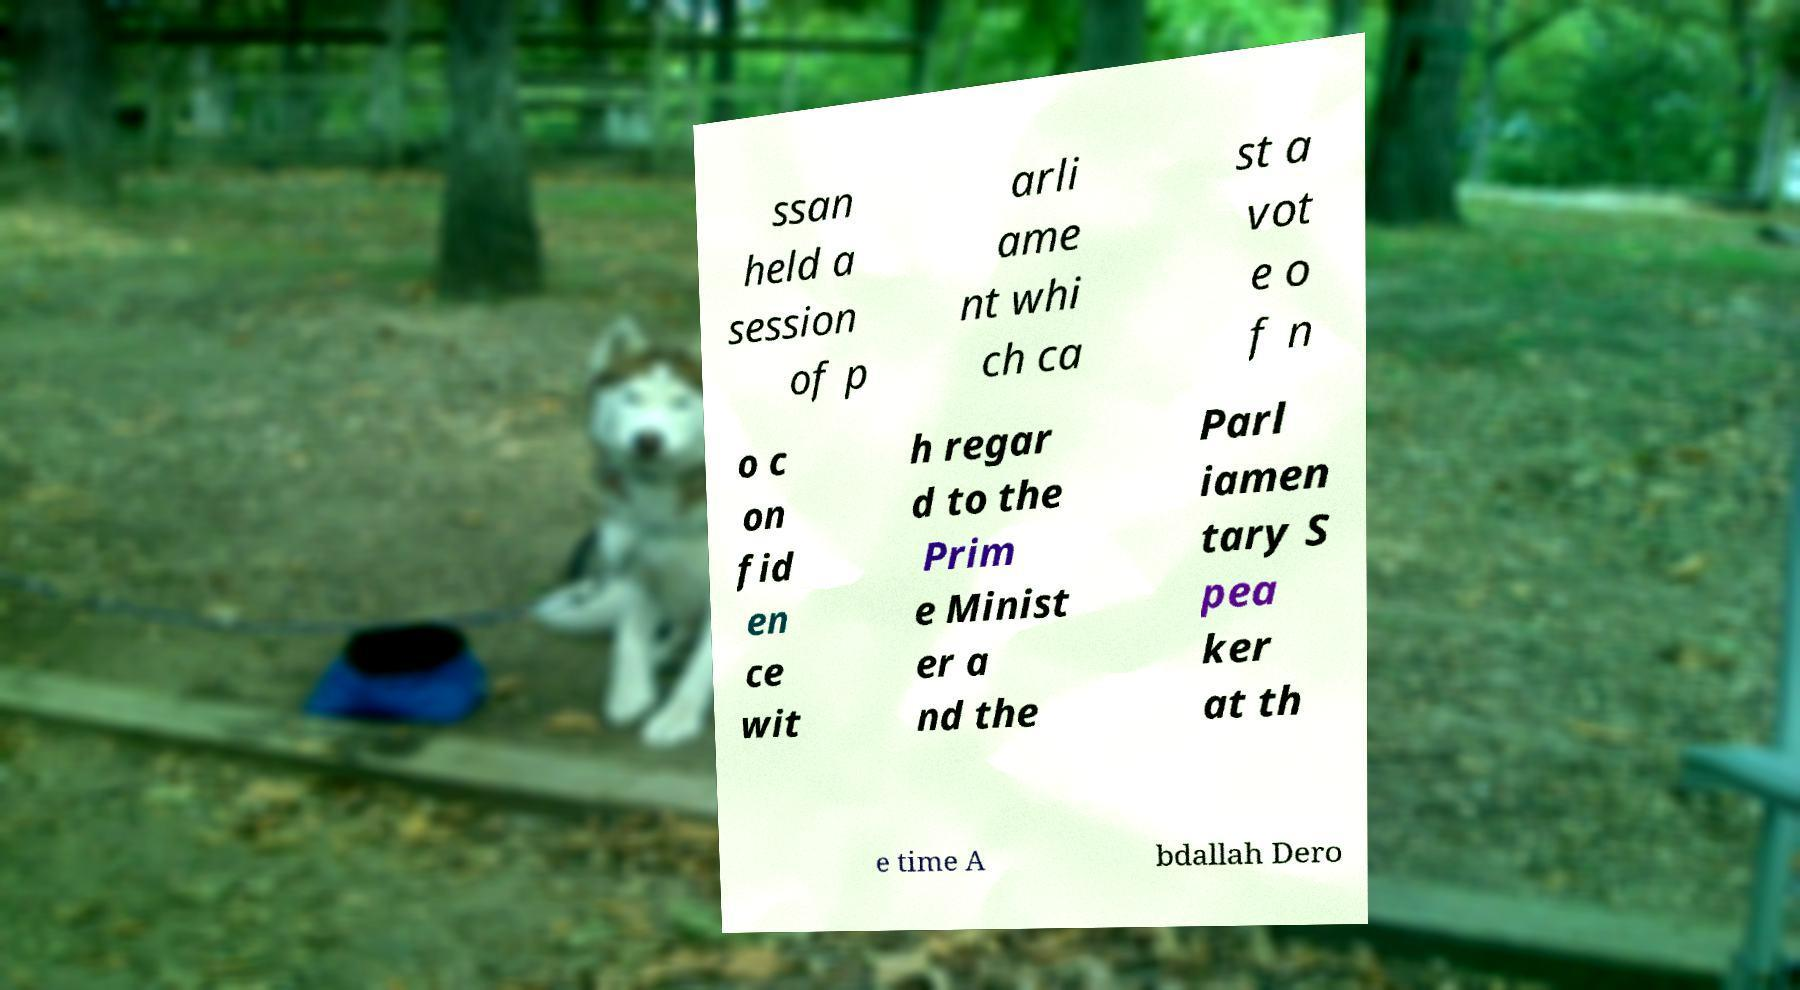Please read and relay the text visible in this image. What does it say? ssan held a session of p arli ame nt whi ch ca st a vot e o f n o c on fid en ce wit h regar d to the Prim e Minist er a nd the Parl iamen tary S pea ker at th e time A bdallah Dero 